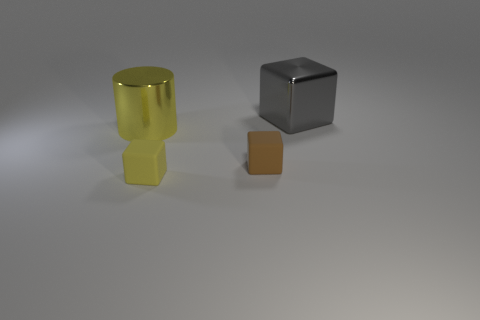What number of other things are the same size as the gray shiny thing?
Your answer should be very brief. 1. What is the shape of the large thing to the left of the brown block that is in front of the block on the right side of the tiny brown rubber cube?
Your answer should be compact. Cylinder. There is a gray shiny thing; is its size the same as the yellow thing behind the yellow matte cube?
Offer a very short reply. Yes. What color is the object that is left of the brown object and to the right of the large yellow metallic cylinder?
Provide a succinct answer. Yellow. What number of other things are the same shape as the tiny yellow object?
Ensure brevity in your answer.  2. Do the metal object that is in front of the gray shiny thing and the tiny matte cube that is right of the small yellow block have the same color?
Offer a terse response. No. Does the object to the left of the yellow matte cube have the same size as the matte block behind the yellow matte cube?
Your response must be concise. No. Is there any other thing that is the same material as the big cylinder?
Your answer should be compact. Yes. What is the large object that is behind the shiny object that is to the left of the big shiny thing on the right side of the large cylinder made of?
Make the answer very short. Metal. Do the large yellow shiny object and the gray object have the same shape?
Provide a succinct answer. No. 